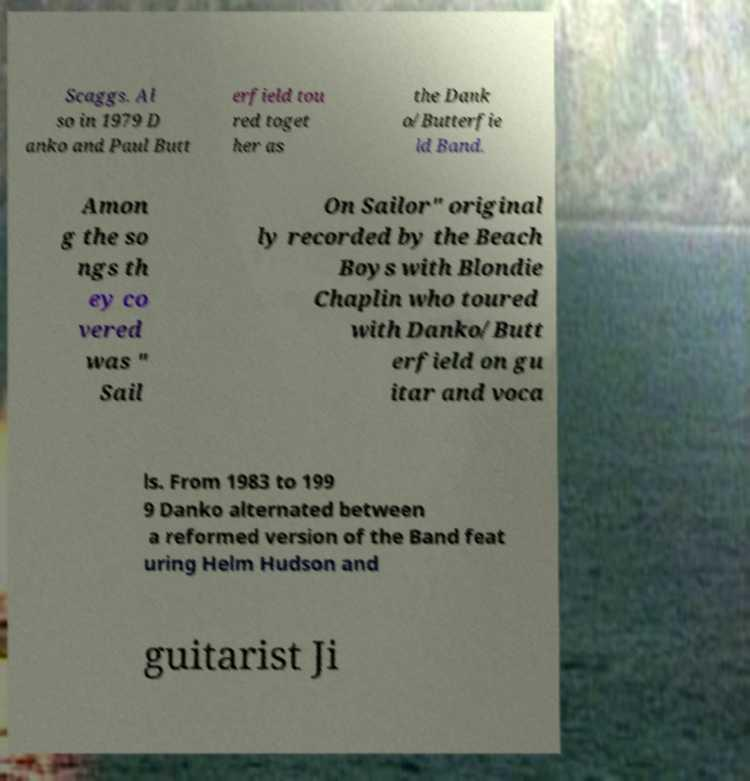I need the written content from this picture converted into text. Can you do that? Scaggs. Al so in 1979 D anko and Paul Butt erfield tou red toget her as the Dank o/Butterfie ld Band. Amon g the so ngs th ey co vered was " Sail On Sailor" original ly recorded by the Beach Boys with Blondie Chaplin who toured with Danko/Butt erfield on gu itar and voca ls. From 1983 to 199 9 Danko alternated between a reformed version of the Band feat uring Helm Hudson and guitarist Ji 